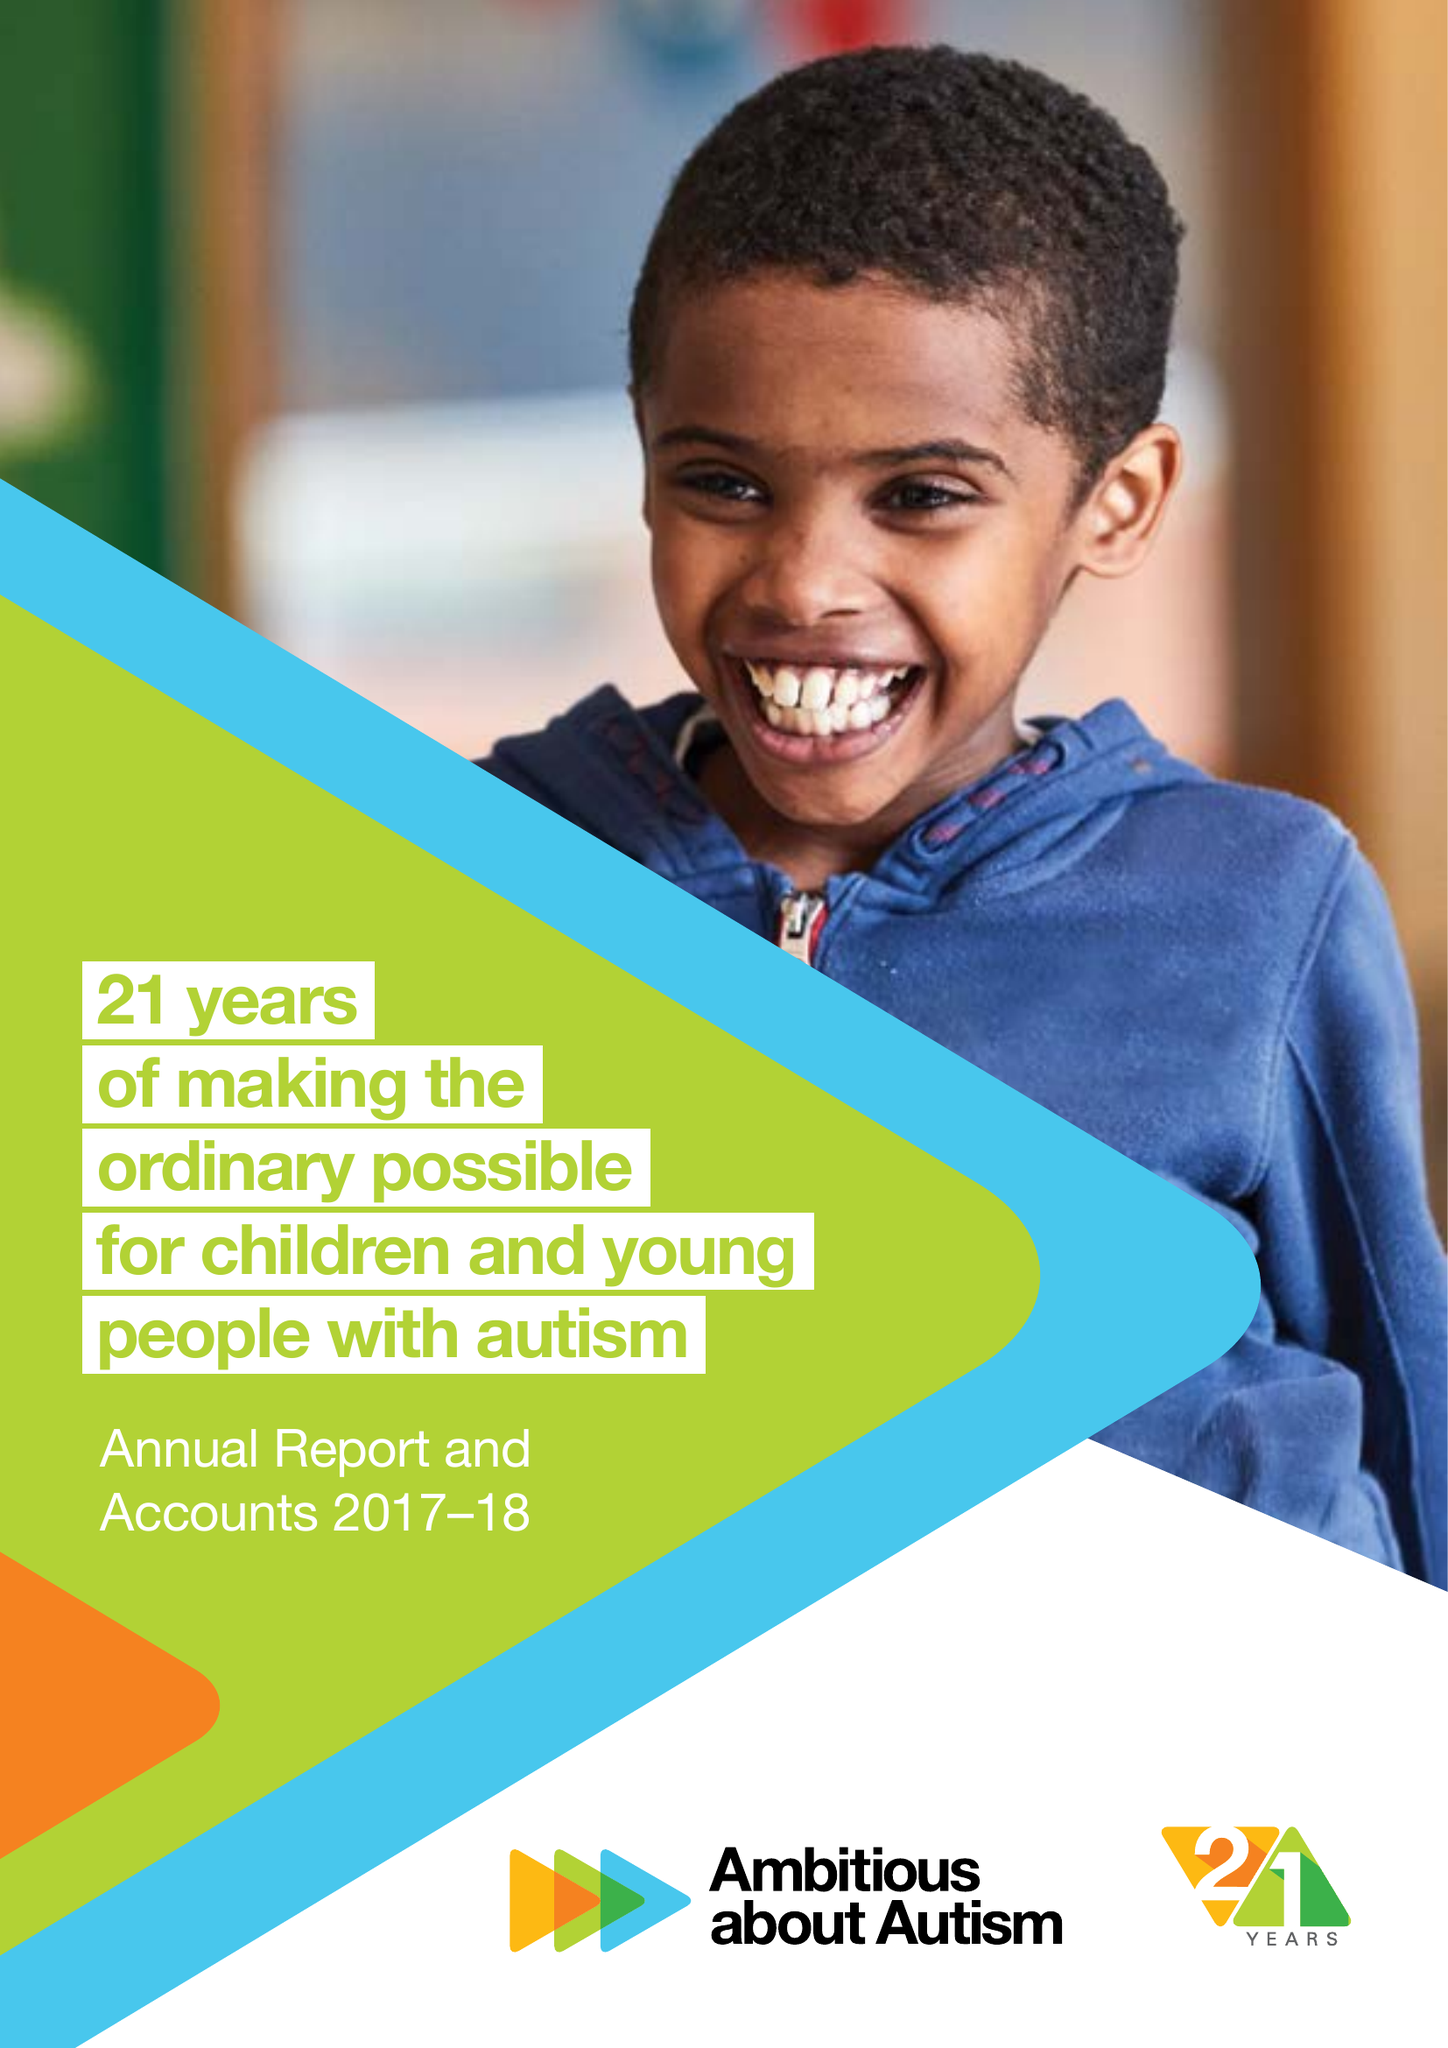What is the value for the address__postcode?
Answer the question using a single word or phrase. N10 3JA 